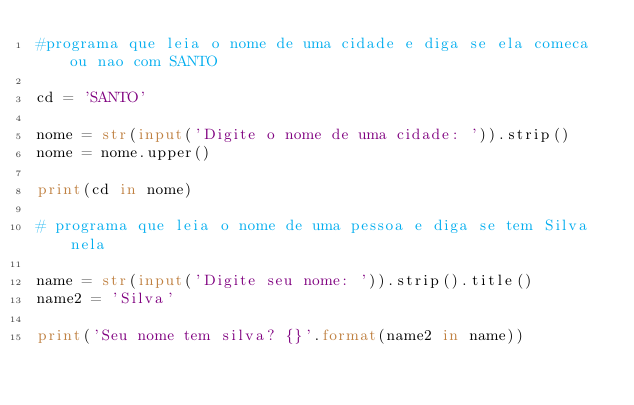Convert code to text. <code><loc_0><loc_0><loc_500><loc_500><_Python_>#programa que leia o nome de uma cidade e diga se ela comeca ou nao com SANTO

cd = 'SANTO'

nome = str(input('Digite o nome de uma cidade: ')).strip()
nome = nome.upper()

print(cd in nome)

# programa que leia o nome de uma pessoa e diga se tem Silva nela

name = str(input('Digite seu nome: ')).strip().title()
name2 = 'Silva'

print('Seu nome tem silva? {}'.format(name2 in name))</code> 